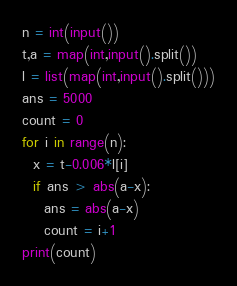<code> <loc_0><loc_0><loc_500><loc_500><_Python_>n = int(input())
t,a = map(int,input().split())
l = list(map(int,input().split()))
ans = 5000
count = 0
for i in range(n):
  x = t-0.006*l[i]
  if ans > abs(a-x):
    ans = abs(a-x)
    count = i+1
print(count)</code> 